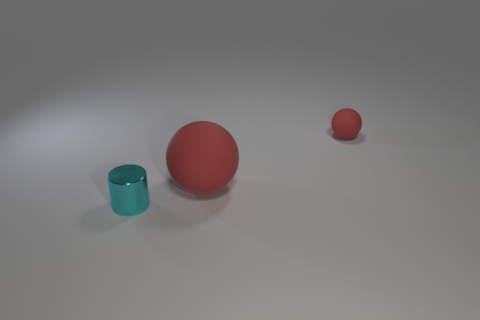Imagine these objects were part of a story. What role might they play? In a narrative, the large red ball could symbolize a central character or an important element of the plot due to its prominence. The blue cup might represent a sidekick or a useful item to aid in a quest. The tiny red ball could be a subtle yet crucial detail that plays a key role in the story's climax or resolution. 